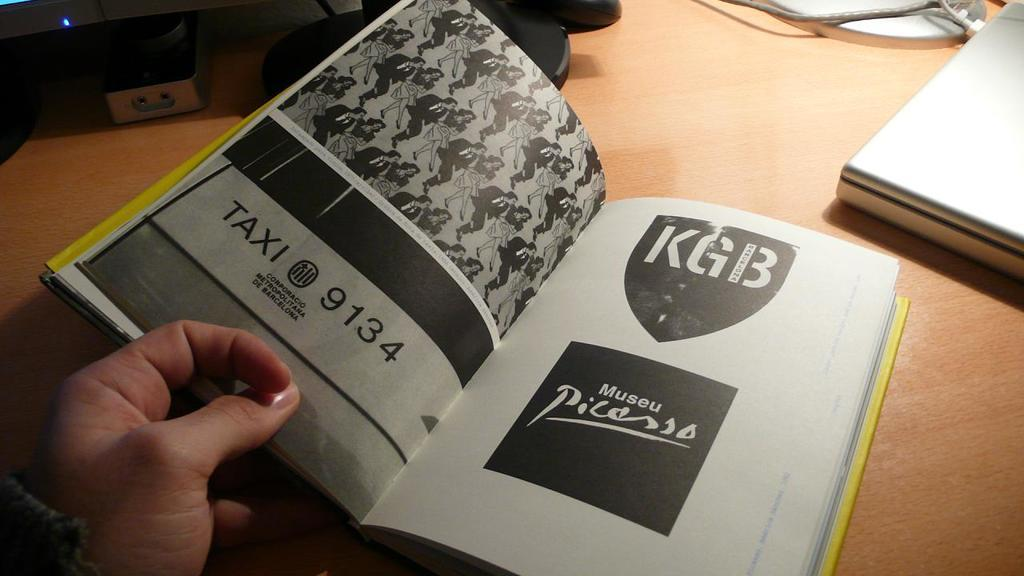Provide a one-sentence caption for the provided image. a book someone has open with Taxi 9134, KGB, and Picasso on the pages. 